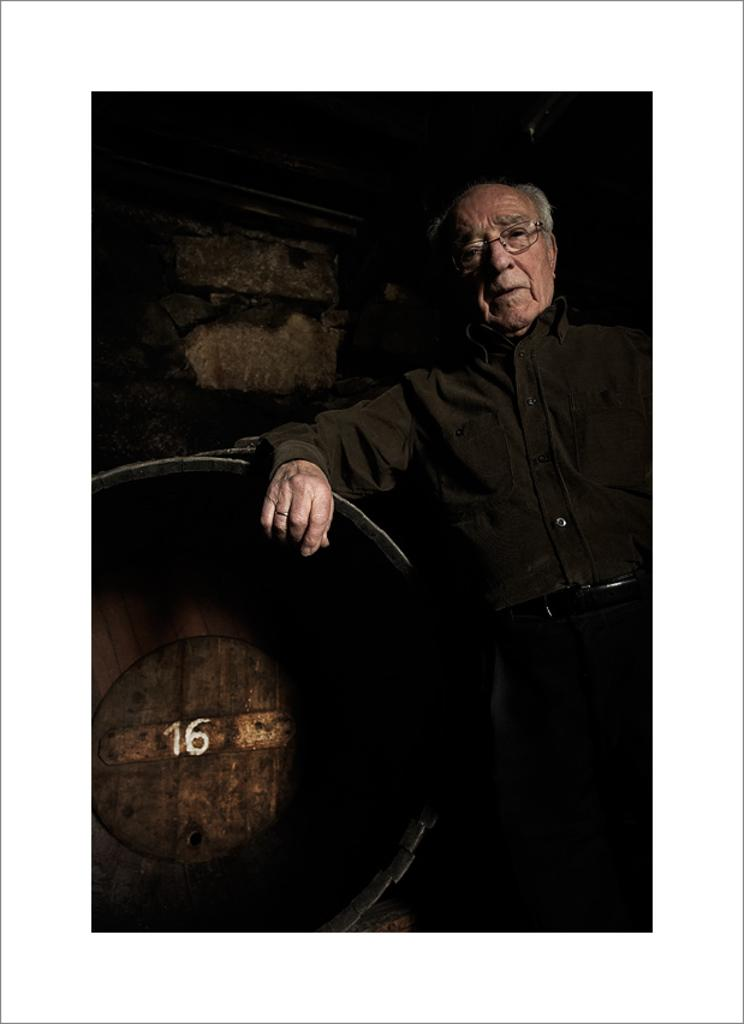Who is the main subject in the picture? There is an old man in the picture. What is the old man doing in the image? The old man is standing and leaning on a round substance. What is the old man wearing? The old man is wearing a black shirt and black trousers. He is also wearing a belt. What can be seen behind the old man in the image? There is a wall visible behind the old man. What type of mist can be seen surrounding the old man in the image? There is no mist present in the image; it is a clear scene with the old man standing and leaning on a round substance. 